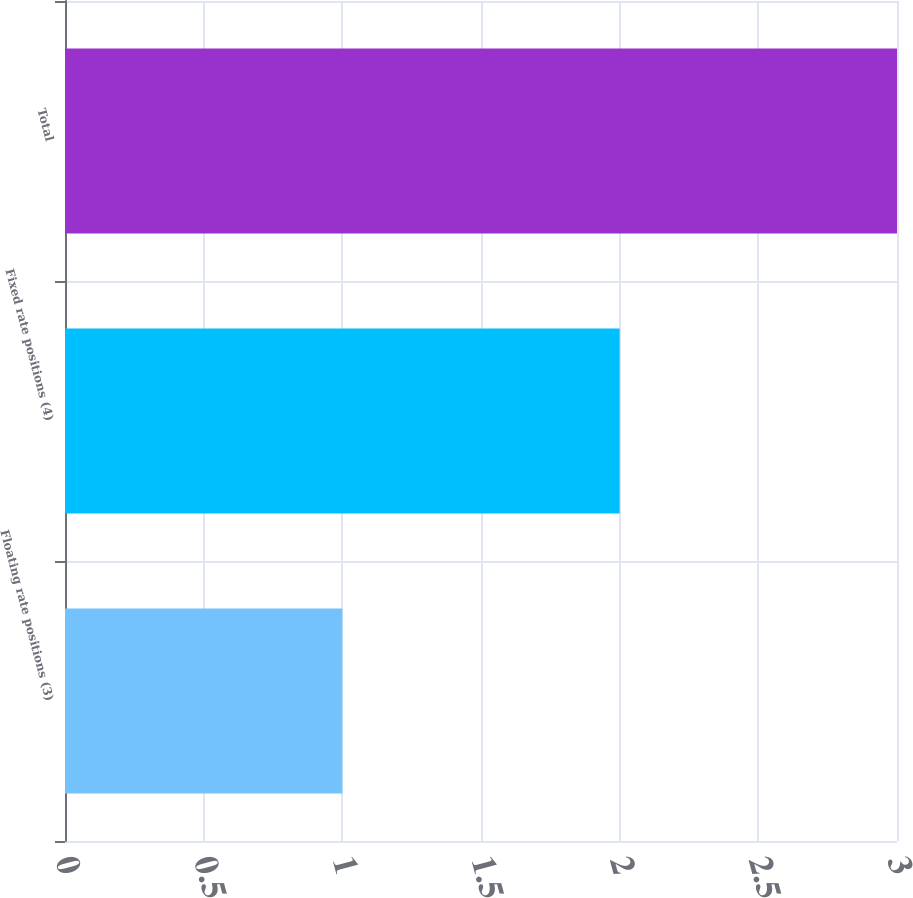Convert chart. <chart><loc_0><loc_0><loc_500><loc_500><bar_chart><fcel>Floating rate positions (3)<fcel>Fixed rate positions (4)<fcel>Total<nl><fcel>1<fcel>2<fcel>3<nl></chart> 